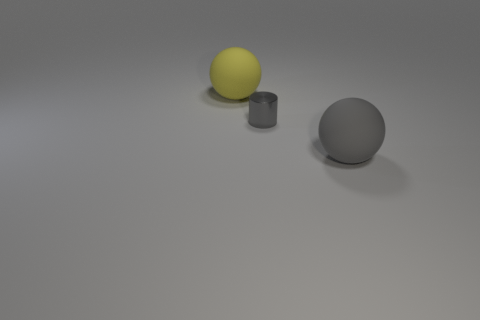There is a big matte sphere that is to the right of the yellow ball; is it the same color as the cylinder?
Keep it short and to the point. Yes. The yellow matte object is what size?
Your answer should be very brief. Large. There is a matte sphere behind the big rubber object that is to the right of the small shiny thing; how big is it?
Offer a very short reply. Large. How many rubber objects are the same color as the small metal cylinder?
Offer a terse response. 1. What number of large purple matte cubes are there?
Offer a terse response. 0. What number of other big things have the same material as the big gray thing?
Offer a terse response. 1. What is the size of the gray object that is the same shape as the yellow thing?
Give a very brief answer. Large. What is the yellow object made of?
Provide a short and direct response. Rubber. There is a gray thing that is in front of the cylinder in front of the big rubber thing that is behind the tiny gray shiny cylinder; what is it made of?
Give a very brief answer. Rubber. Are there any other things that have the same shape as the big gray object?
Keep it short and to the point. Yes. 